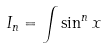<formula> <loc_0><loc_0><loc_500><loc_500>I _ { n } = \int \sin ^ { n } x</formula> 